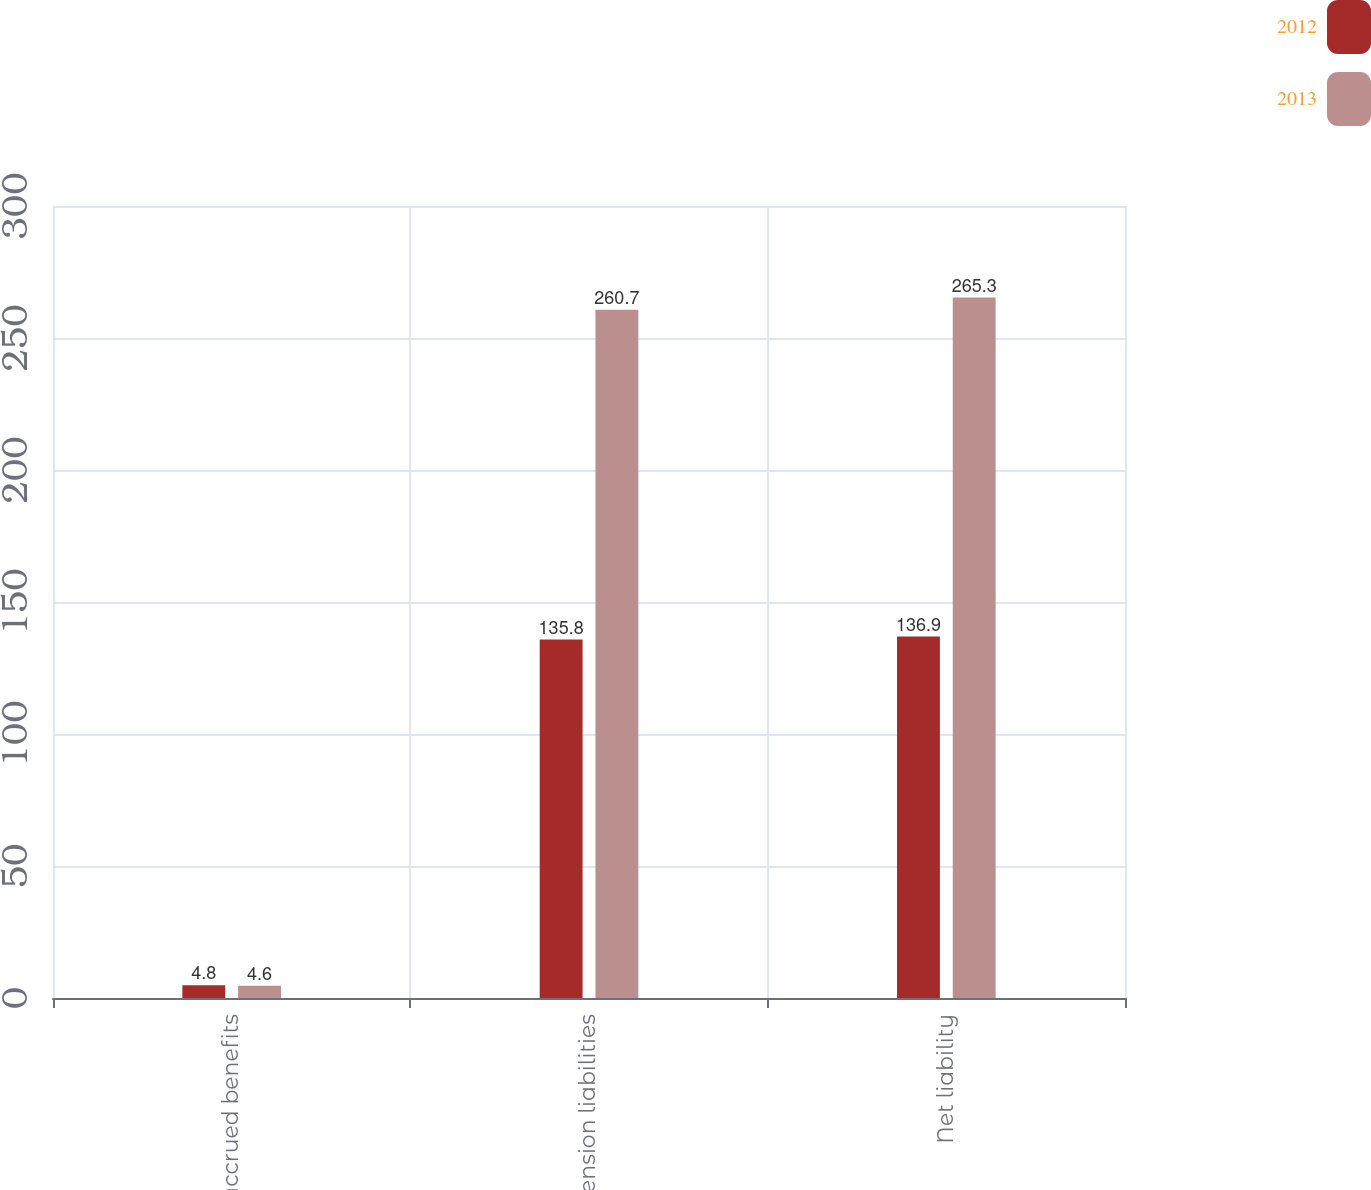Convert chart to OTSL. <chart><loc_0><loc_0><loc_500><loc_500><stacked_bar_chart><ecel><fcel>Accrued benefits<fcel>Pension liabilities<fcel>Net liability<nl><fcel>2012<fcel>4.8<fcel>135.8<fcel>136.9<nl><fcel>2013<fcel>4.6<fcel>260.7<fcel>265.3<nl></chart> 